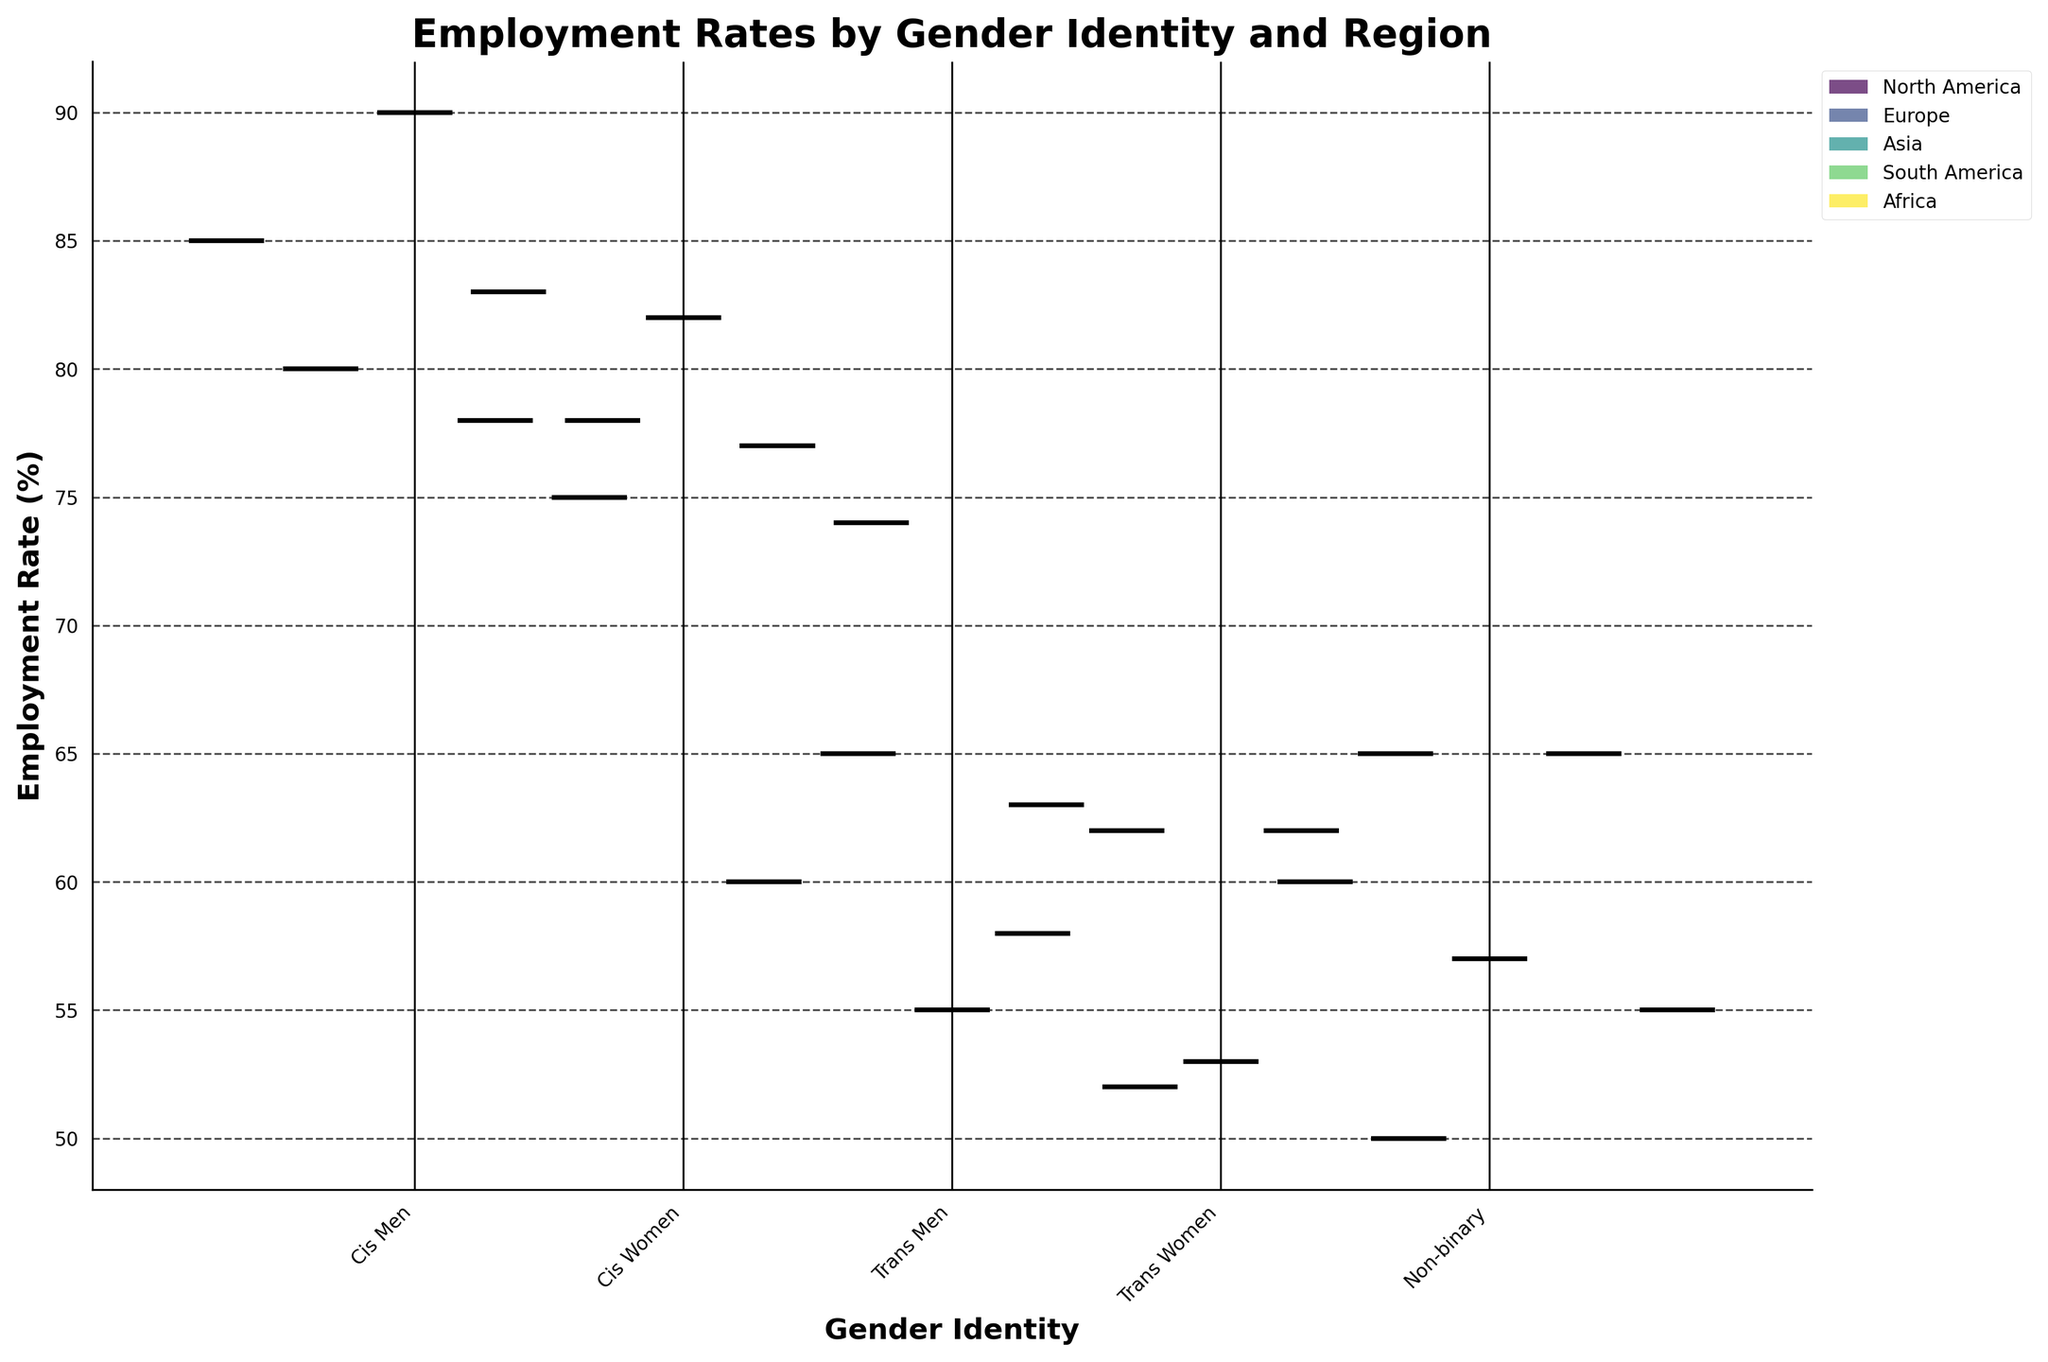What is the title of the figure? The title is generally positioned at the top center of the figure. Here, the title provides a clear and concise description of what the box plot represents.
Answer: Employment Rates by Gender Identity and Region Which group has the highest employment rate in North America? To answer this, locate the section of the box plot corresponding to North America and compare the employment rates of different groups.
Answer: Cis Men What color represents the regions in the legend? The legend elements use different color shades to distinguish between regions. The colors map to regions like North America, Europe, etc.
Answer: Different shades of color (as part of the color gradient) What is the employment rate range for Cis Women in Europe? The box plot for Cis Women in Europe will show the range extending from the minimum to the maximum value, often represented by the whiskers.
Answer: 75 to 67 Which gender identity has the lowest employment rate across all regions? Check all box plots and identify the one with the lowest positioning.
Answer: Trans Women How does job satisfaction compare between Cis Men in North America and Cis Women in Asia? Look at the job satisfaction values for both groups and compare them directly.
Answer: Cis Women in Asia have higher job satisfaction Which region has the largest employment rate disparity between Cis Men and Trans Women? Calculate the difference in employment rates between Cis Men and Trans Women for each region and find the region with the largest disparity.
Answer: Asia How are non-binary individuals performing in terms of employment rate in South America compared to North America? Compare the employment rate of non-binary individuals in both regions by checking their respective box plots.
Answer: Similar What is the median employment rate for Trans Men in Africa? Locate the box plot for Trans Men in Africa and identify the middle value, or the median, across the range.
Answer: 52 Do Cis Women in Africa have a lower employment rate than Cis Men in South America? Compare the median employment rates of Cis Women in Africa to Cis Men in South America, based on their positions.
Answer: Yes 